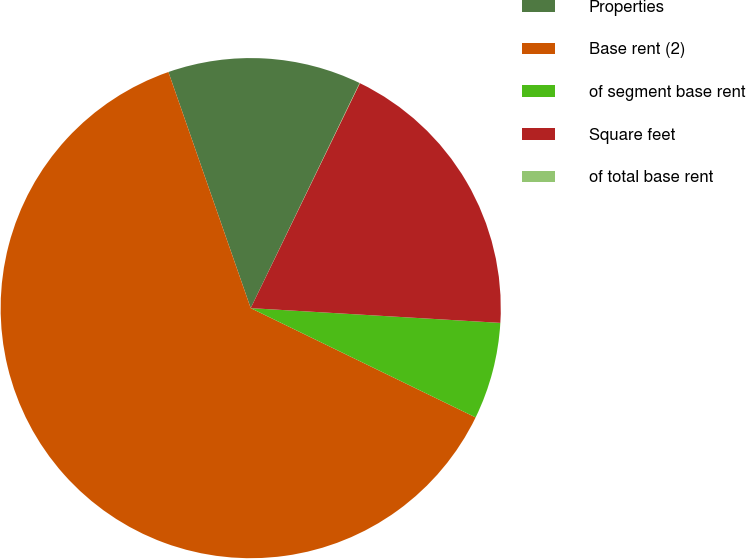<chart> <loc_0><loc_0><loc_500><loc_500><pie_chart><fcel>Properties<fcel>Base rent (2)<fcel>of segment base rent<fcel>Square feet<fcel>of total base rent<nl><fcel>12.51%<fcel>62.47%<fcel>6.26%<fcel>18.75%<fcel>0.02%<nl></chart> 